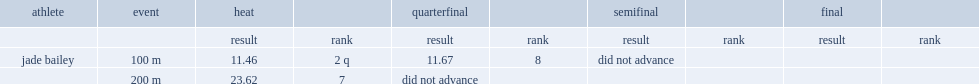What is the result of bailey's 100 m race during quarterfinal? 11.67. 